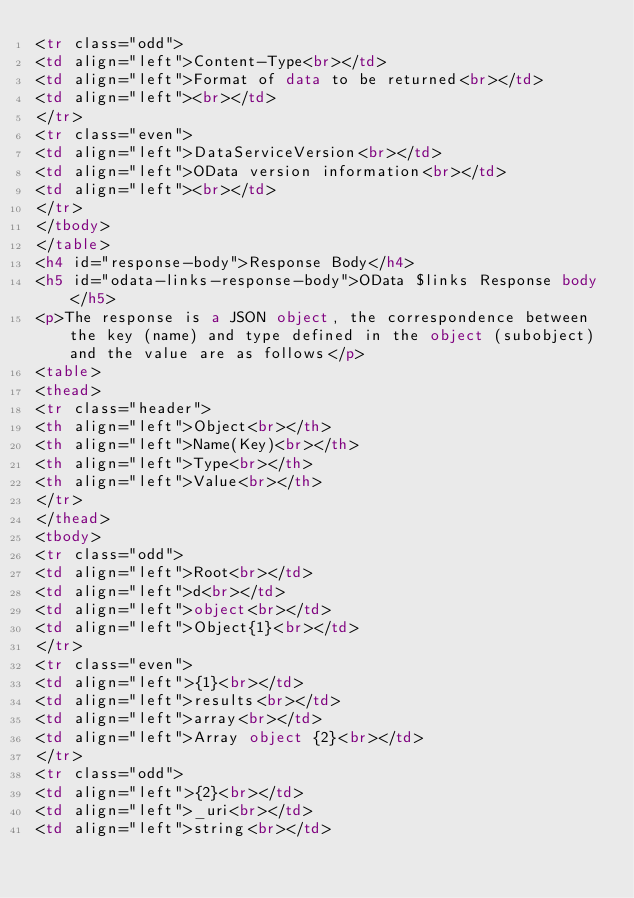Convert code to text. <code><loc_0><loc_0><loc_500><loc_500><_HTML_><tr class="odd">
<td align="left">Content-Type<br></td>
<td align="left">Format of data to be returned<br></td>
<td align="left"><br></td>
</tr>
<tr class="even">
<td align="left">DataServiceVersion<br></td>
<td align="left">OData version information<br></td>
<td align="left"><br></td>
</tr>
</tbody>
</table>
<h4 id="response-body">Response Body</h4>
<h5 id="odata-links-response-body">OData $links Response body</h5>
<p>The response is a JSON object, the correspondence between the key (name) and type defined in the object (subobject) and the value are as follows</p>
<table>
<thead>
<tr class="header">
<th align="left">Object<br></th>
<th align="left">Name(Key)<br></th>
<th align="left">Type<br></th>
<th align="left">Value<br></th>
</tr>
</thead>
<tbody>
<tr class="odd">
<td align="left">Root<br></td>
<td align="left">d<br></td>
<td align="left">object<br></td>
<td align="left">Object{1}<br></td>
</tr>
<tr class="even">
<td align="left">{1}<br></td>
<td align="left">results<br></td>
<td align="left">array<br></td>
<td align="left">Array object {2}<br></td>
</tr>
<tr class="odd">
<td align="left">{2}<br></td>
<td align="left">_uri<br></td>
<td align="left">string<br></td></code> 